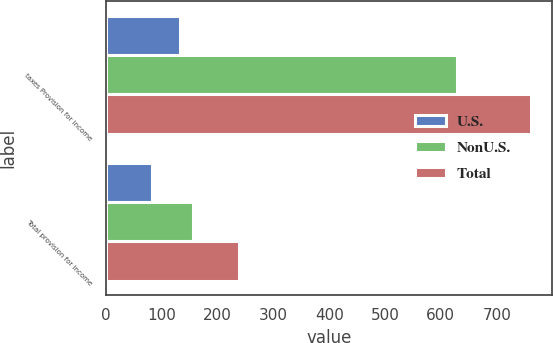Convert chart. <chart><loc_0><loc_0><loc_500><loc_500><stacked_bar_chart><ecel><fcel>taxes Provision for income<fcel>Total provision for income<nl><fcel>U.S.<fcel>132.3<fcel>82.7<nl><fcel>NonU.S.<fcel>628.7<fcel>155.9<nl><fcel>Total<fcel>761<fcel>238.6<nl></chart> 